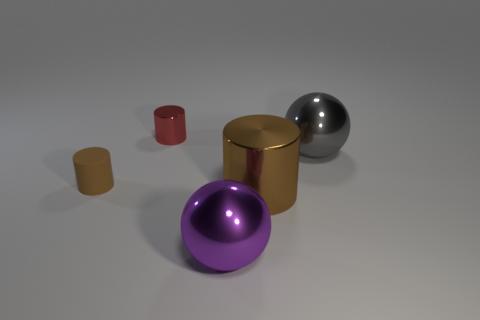The other large cylinder that is made of the same material as the red cylinder is what color?
Offer a terse response. Brown. What number of rubber objects are big purple spheres or small things?
Offer a very short reply. 1. What shape is the brown metal thing that is the same size as the gray shiny thing?
Offer a terse response. Cylinder. How many objects are objects that are left of the tiny red metallic object or cylinders that are on the right side of the tiny brown thing?
Ensure brevity in your answer.  3. There is a cylinder that is the same size as the red metallic object; what material is it?
Make the answer very short. Rubber. How many other things are the same material as the tiny brown cylinder?
Make the answer very short. 0. Are there an equal number of large metallic cylinders that are on the left side of the purple metal sphere and metallic cylinders that are on the right side of the large gray sphere?
Give a very brief answer. Yes. What number of brown objects are either large cylinders or small balls?
Ensure brevity in your answer.  1. Is the color of the large shiny cylinder the same as the tiny cylinder to the left of the small red metal cylinder?
Your answer should be compact. Yes. How many other things are the same color as the tiny metal cylinder?
Your response must be concise. 0. 